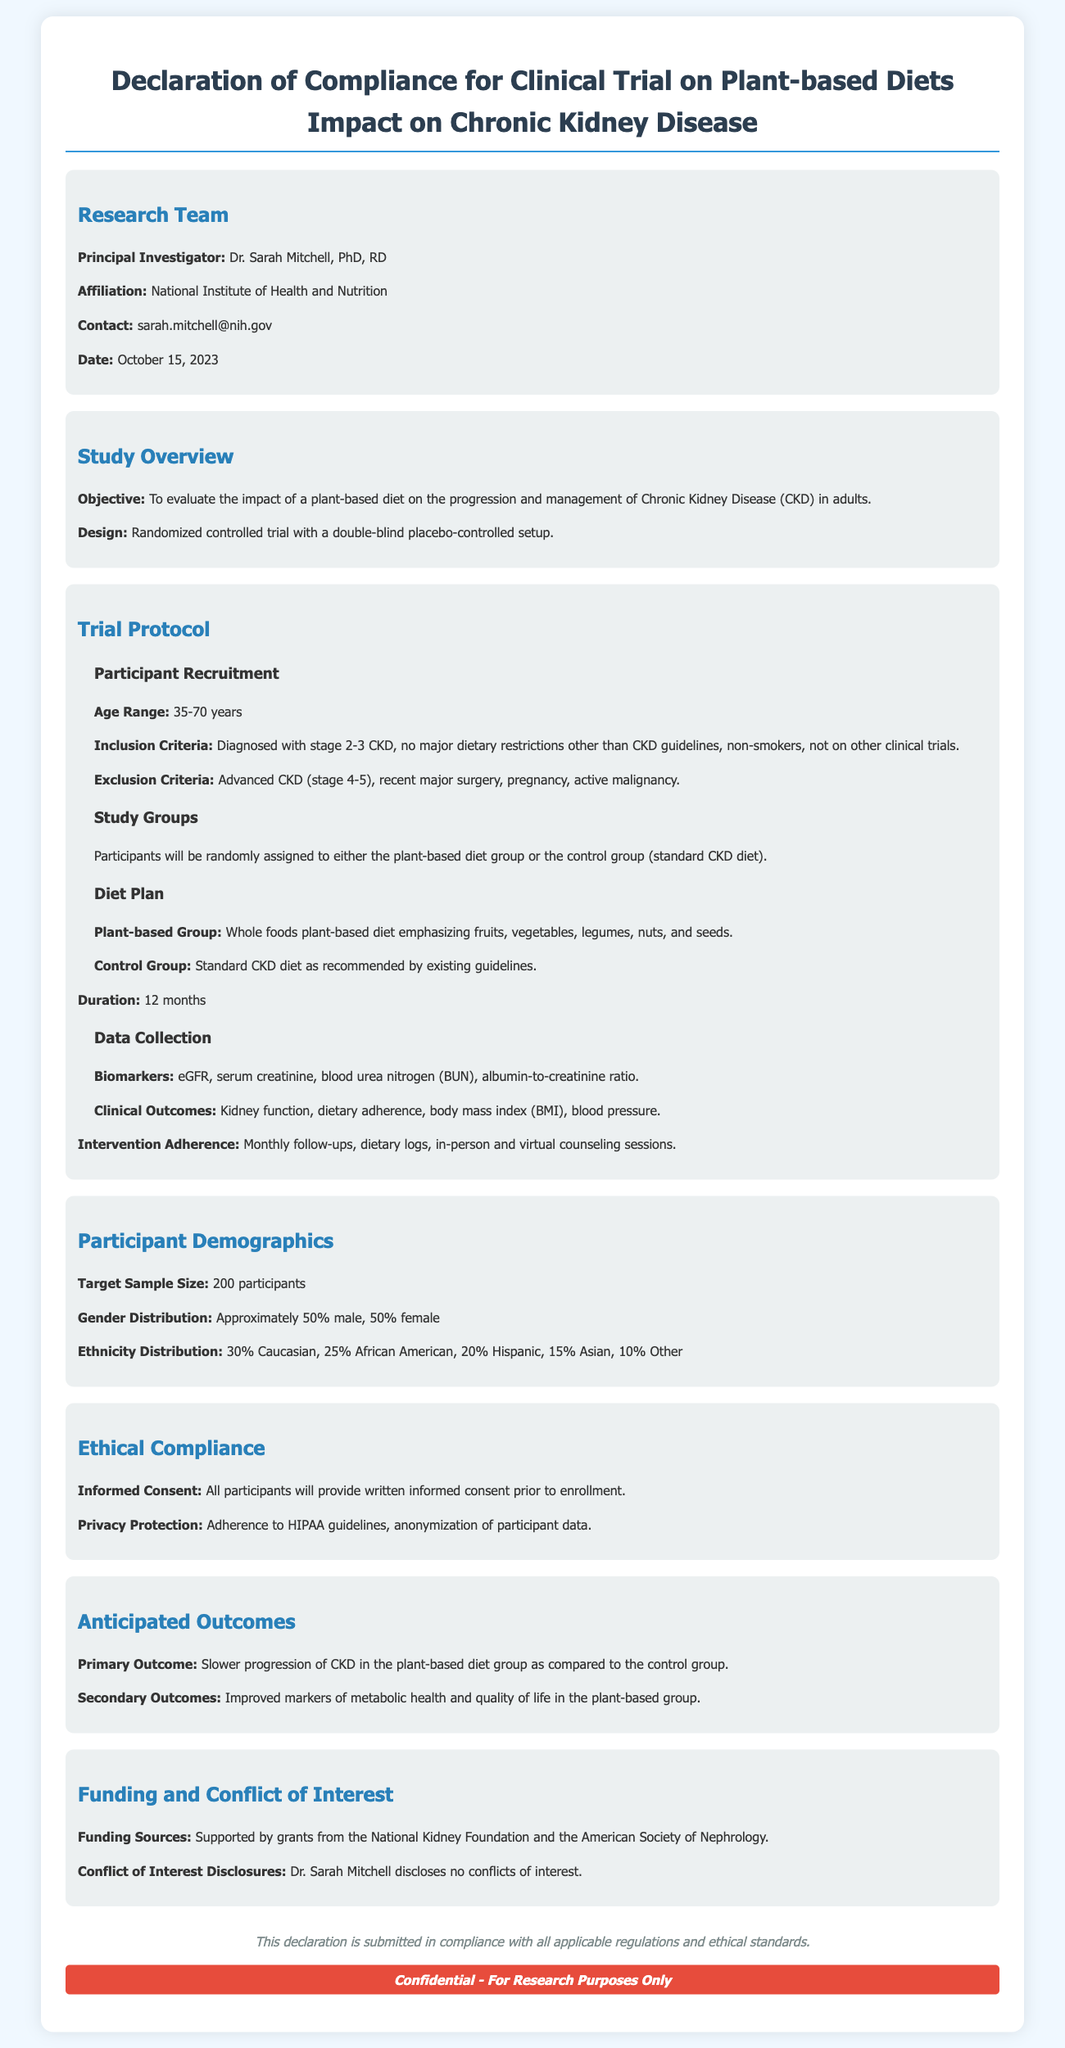What is the name of the principal investigator? The principal investigator is the lead researcher of the study, which is specified in the document.
Answer: Dr. Sarah Mitchell What is the age range for participant recruitment? The age range is mentioned under the recruitment section of the trial protocol, indicating eligible ages for participation.
Answer: 35-70 years What is the target sample size for the study? The target sample size is clearly stated in the participant demographics section for clarity on the scale of the research.
Answer: 200 participants What percentage of participants will be male? The gender distribution data provides the percentage of male participants specifically.
Answer: Approximately 50% What is the duration of the clinical trial? The duration of the study is outlined in the trial protocol section, indicating how long participants will be involved.
Answer: 12 months What is the primary outcome anticipated from the study? The anticipated primary outcome is described, specifying the main finding researchers aim to observe.
Answer: Slower progression of CKD What is the affiliation of the principal investigator? The document mentions the institution where the principal investigator is working, which is relevant for establishing the authority and credibility.
Answer: National Institute of Health and Nutrition What guidelines are participants expected to adhere to regarding dietary restrictions? The inclusion and exclusion criteria specify the dietary restrictions relevant to participant eligibility, which may impact adherence to the study.
Answer: CKD guidelines What funding sources are listed for the clinical trial? The funding sources are identified in the document, providing transparency about the financial backing of the research.
Answer: National Kidney Foundation and the American Society of Nephrology 